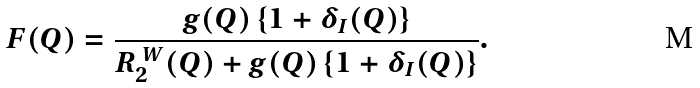Convert formula to latex. <formula><loc_0><loc_0><loc_500><loc_500>F ( Q ) = \frac { g ( Q ) \left \{ 1 + \delta _ { I } ( Q ) \right \} } { R _ { 2 } ^ { \ W } ( Q ) + g ( Q ) \left \{ 1 + \delta _ { I } ( Q ) \right \} } .</formula> 